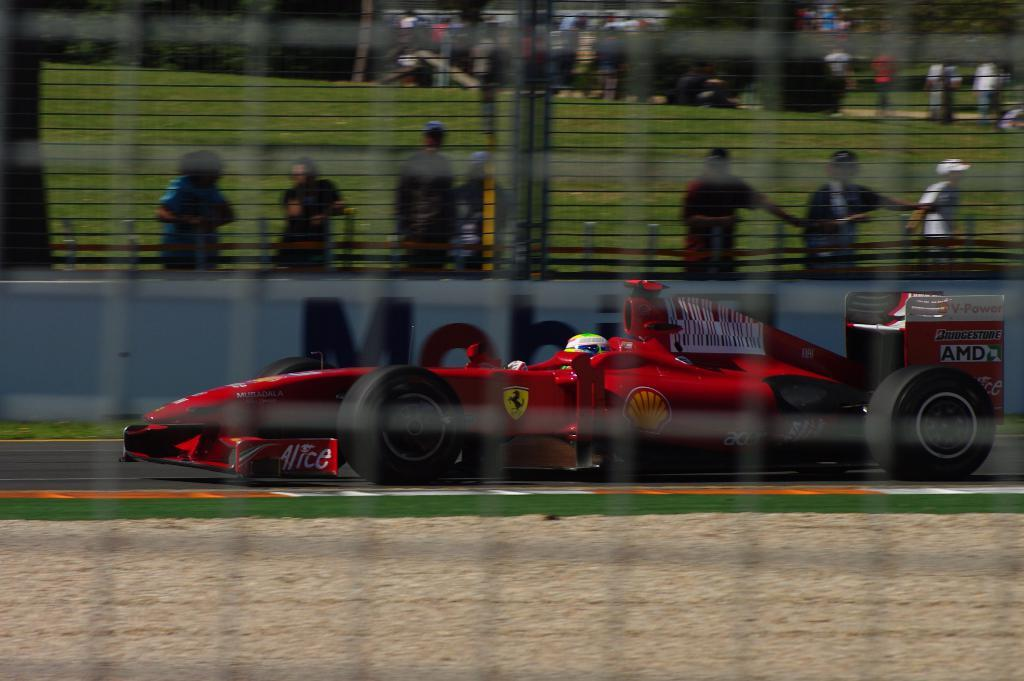What is present in the image that might be used for catching or holding objects? There is a net in the image. What can be seen in the distance in the image? There is a car in the background of the image. What decorative elements are present in the background of the image? There are banners in the background of the image. How many people are visible in the image? There are many people in the image. What type of headwear is worn by some of the people in the image? Some people are wearing caps. What is the price of the building in the image? There is no building present in the image, so it is not possible to determine its price. What type of arch can be seen in the image? There is no arch present in the image. 